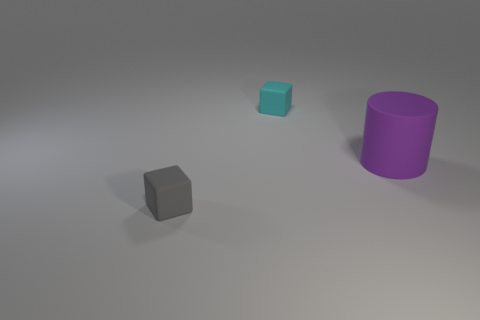Do the purple cylinder that is to the right of the cyan rubber cube and the tiny gray cube have the same size?
Provide a short and direct response. No. There is another tiny rubber object that is the same shape as the tiny cyan matte thing; what color is it?
Your answer should be compact. Gray. Is there any other thing that is the same shape as the big purple rubber thing?
Give a very brief answer. No. The thing behind the big purple rubber thing has what shape?
Your answer should be very brief. Cube. What number of gray rubber objects are the same shape as the cyan matte object?
Ensure brevity in your answer.  1. There is a block left of the cyan matte block; does it have the same color as the tiny rubber thing that is behind the cylinder?
Make the answer very short. No. How many things are cyan things or green metallic cylinders?
Provide a succinct answer. 1. How many tiny gray cubes are the same material as the small cyan block?
Provide a succinct answer. 1. Is the number of large matte cylinders less than the number of big blue spheres?
Your answer should be very brief. No. Is the cube that is in front of the purple object made of the same material as the cyan thing?
Keep it short and to the point. Yes. 